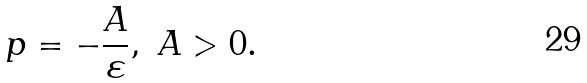<formula> <loc_0><loc_0><loc_500><loc_500>p = - \frac { A } { \varepsilon } , \ A > 0 .</formula> 